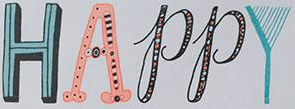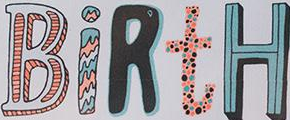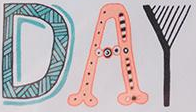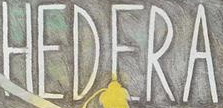Transcribe the words shown in these images in order, separated by a semicolon. HAPPY; BiRtH; DAY; HEDERA 